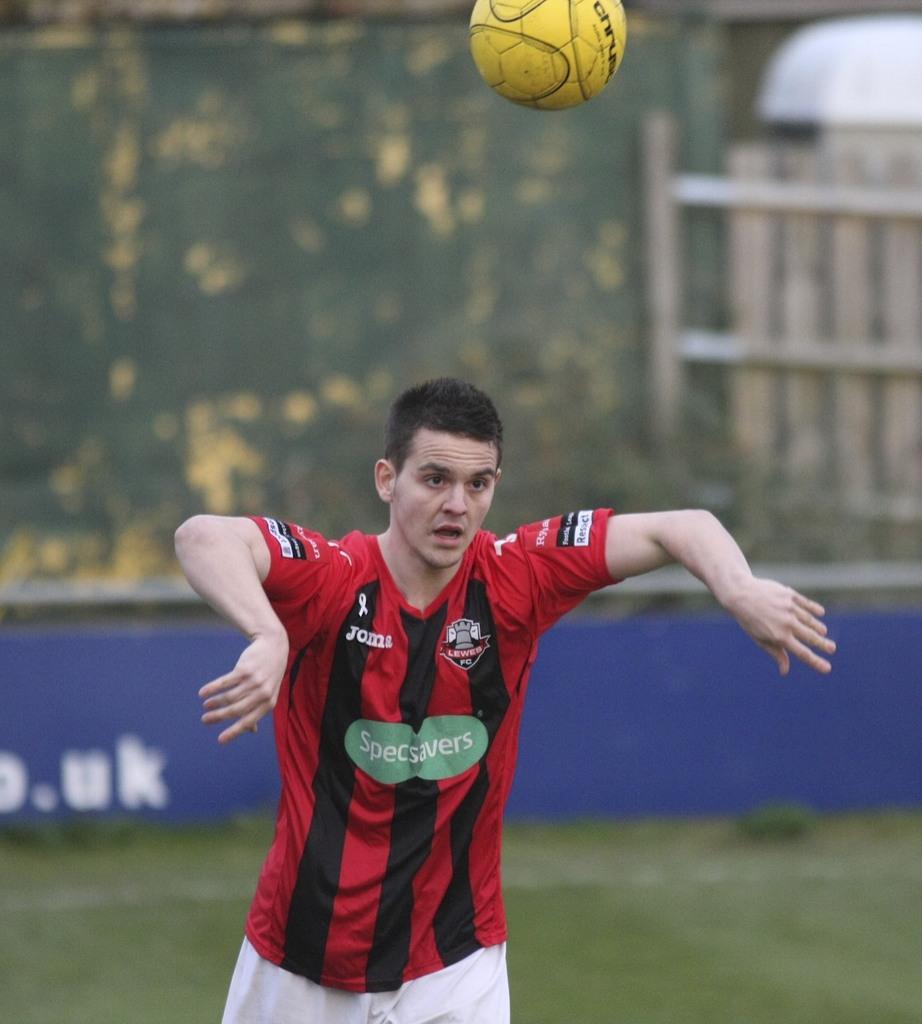Is he on the specsavers team?
Ensure brevity in your answer.  Yes. What team is the person on?
Offer a very short reply. Specsavers. 